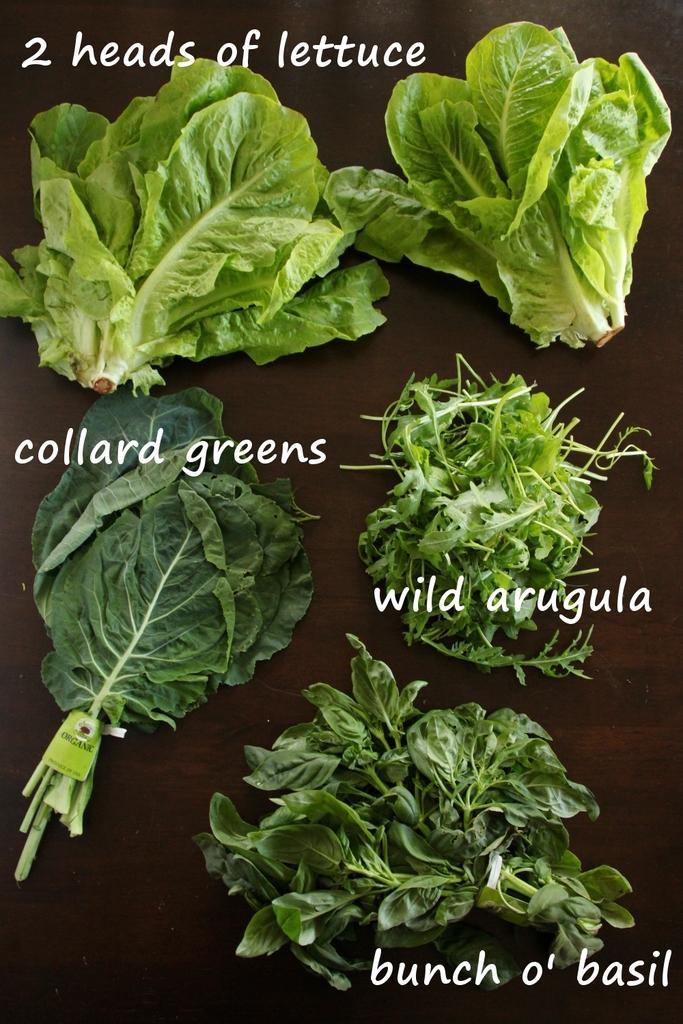Can you describe this image briefly? In this image there are two heads of lettuce and collard greens, wild arugula and bunch of basil. 